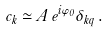<formula> <loc_0><loc_0><loc_500><loc_500>c _ { k } \simeq A \, e ^ { i \varphi _ { 0 } } \delta _ { k q } \, .</formula> 